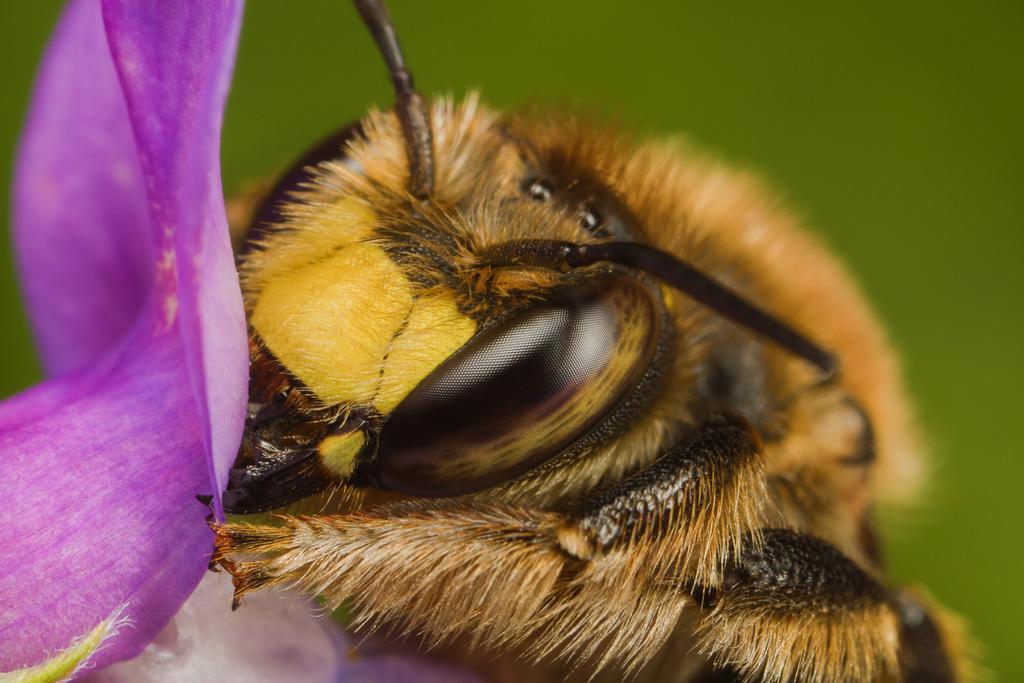In one or two sentences, can you explain what this image depicts? As we can see in the image there is a bird and flower. The background is blurred. 